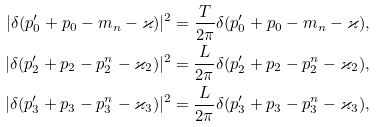Convert formula to latex. <formula><loc_0><loc_0><loc_500><loc_500>| \delta ( p _ { 0 } ^ { \prime } + p _ { 0 } - m _ { n } - \varkappa ) | ^ { 2 } = \frac { T } { 2 \pi } \delta ( p _ { 0 } ^ { \prime } + p _ { 0 } - m _ { n } - \varkappa ) , \\ | \delta ( p _ { 2 } ^ { \prime } + p _ { 2 } - p _ { 2 } ^ { n } - \varkappa _ { 2 } ) | ^ { 2 } = \frac { L } { 2 \pi } \delta ( p _ { 2 } ^ { \prime } + p _ { 2 } - p _ { 2 } ^ { n } - \varkappa _ { 2 } ) , \\ | \delta ( p _ { 3 } ^ { \prime } + p _ { 3 } - p _ { 3 } ^ { n } - \varkappa _ { 3 } ) | ^ { 2 } = \frac { L } { 2 \pi } \delta ( p _ { 3 } ^ { \prime } + p _ { 3 } - p _ { 3 } ^ { n } - \varkappa _ { 3 } ) ,</formula> 